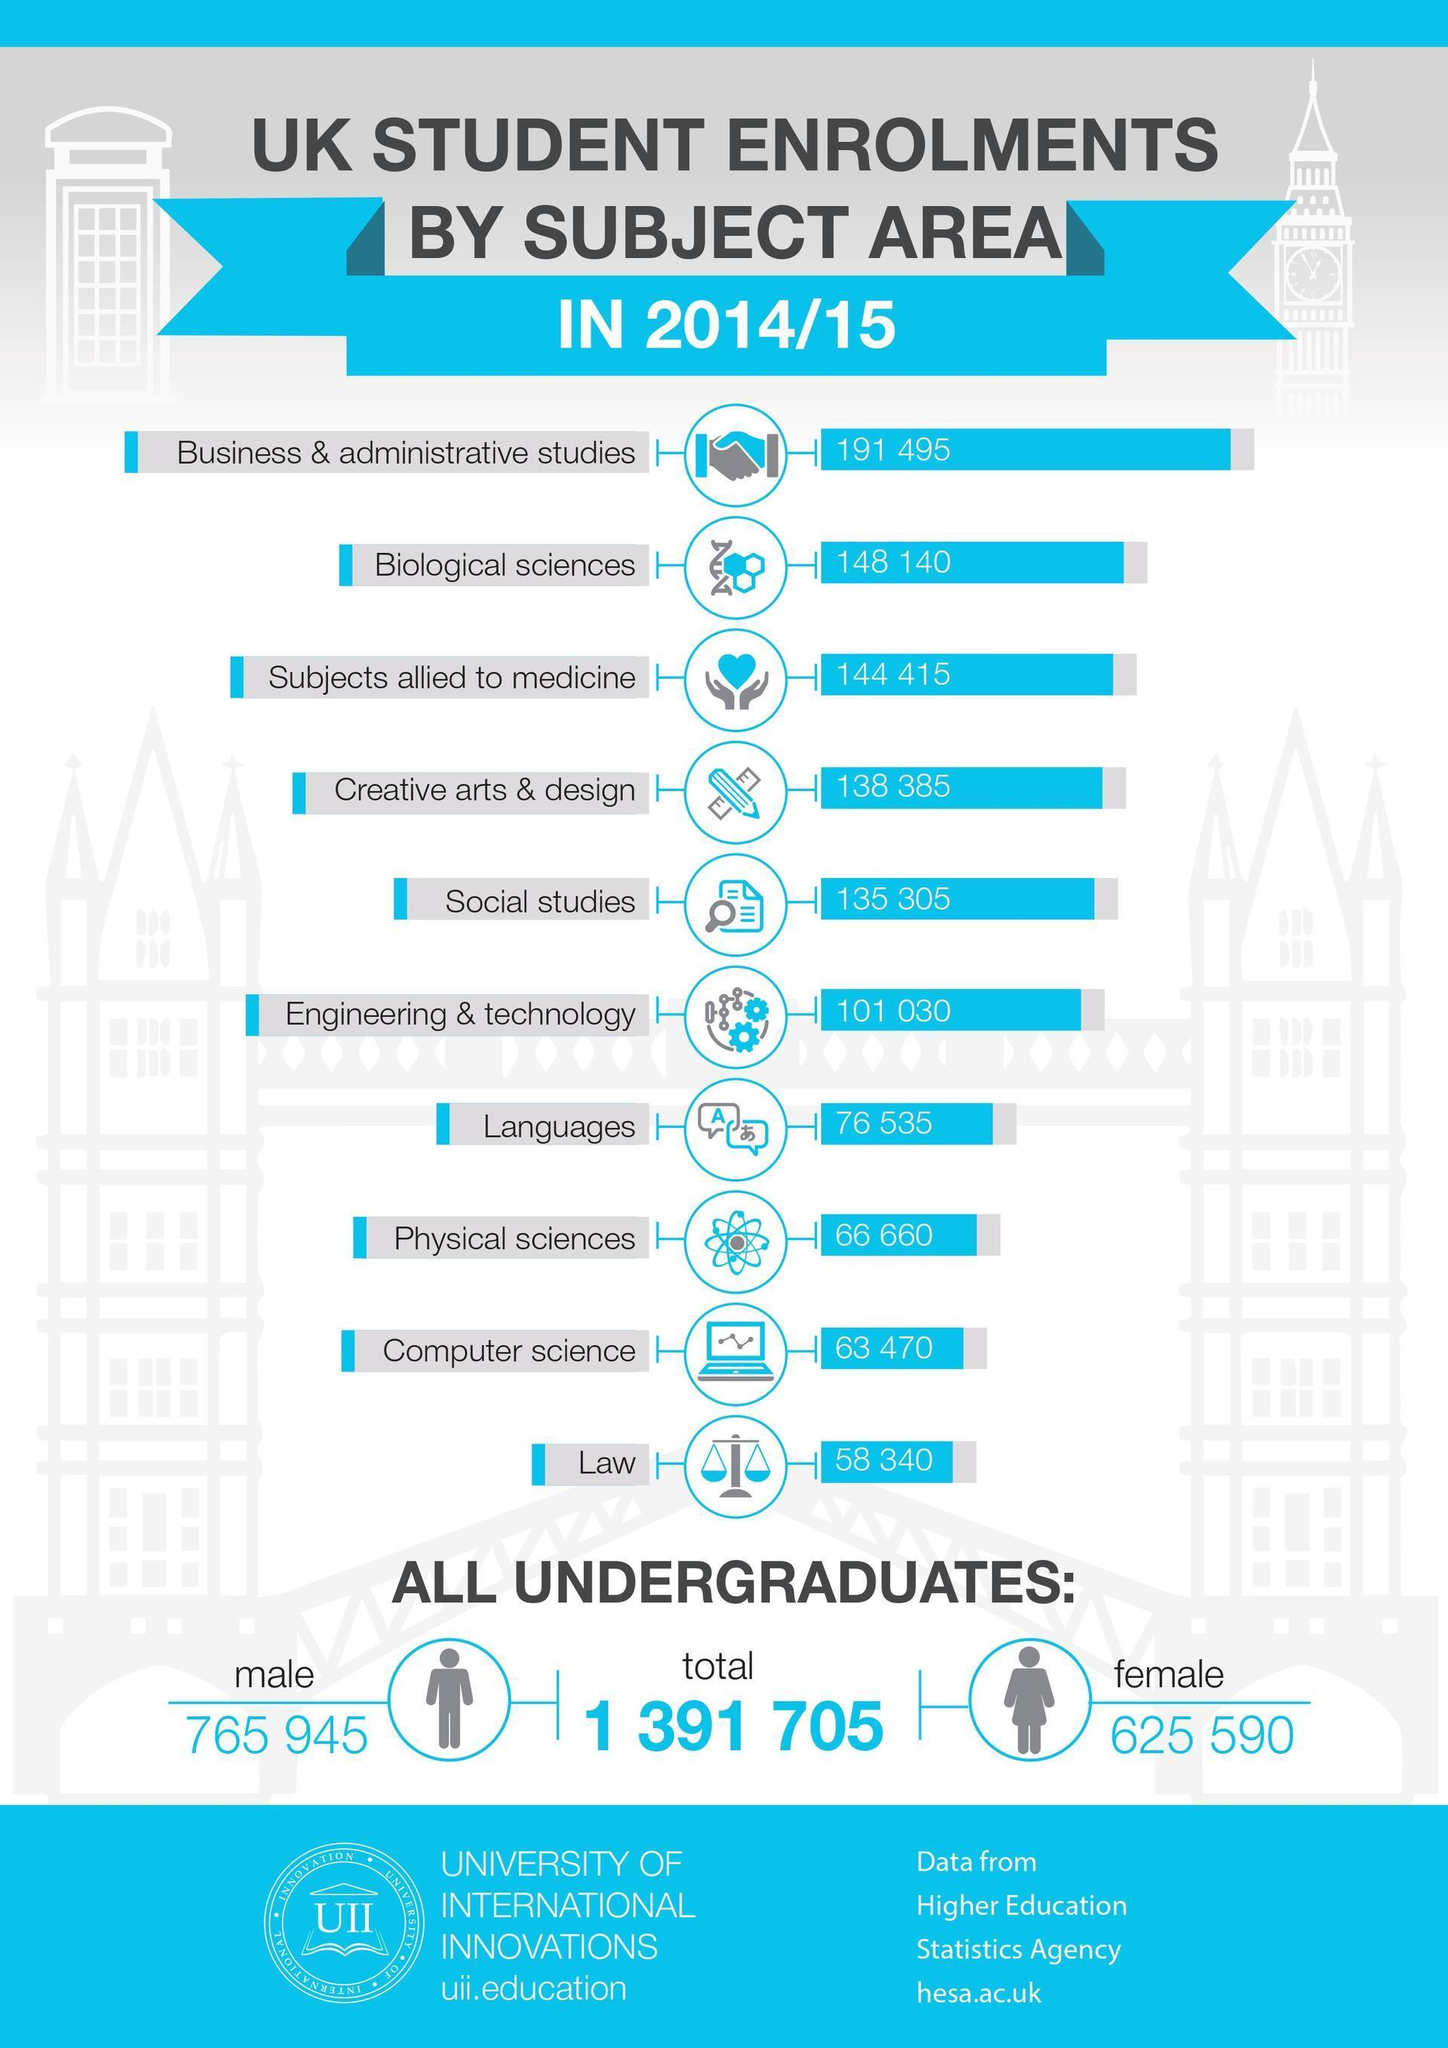How many females are undergraduates?
Answer the question with a short phrase. 625 590 Which subject has the most number of students enrolled? Business & administrative studies How many students have enrolled for Biological sciences and subjects allied to medicine? 292555 